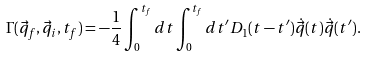Convert formula to latex. <formula><loc_0><loc_0><loc_500><loc_500>\Gamma ( \vec { q } _ { f } , \vec { q } _ { i } , t _ { f } ) = - \frac { 1 } { 4 } \int _ { 0 } ^ { t _ { f } } d t \int _ { 0 } ^ { t _ { f } } d t ^ { \prime } D _ { 1 } ( t - t ^ { \prime } ) \dot { \vec { q } } ( t ) \dot { \vec { q } } ( t ^ { \prime } ) .</formula> 